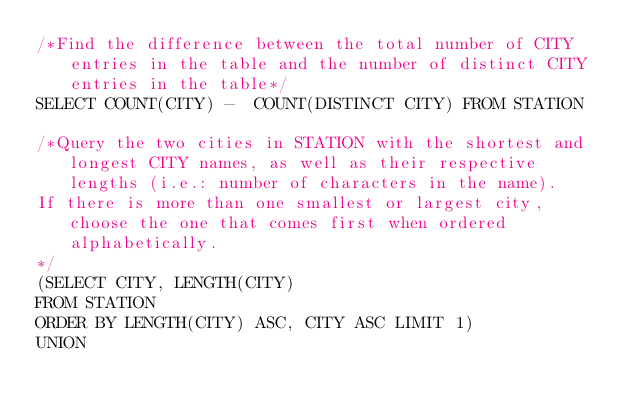<code> <loc_0><loc_0><loc_500><loc_500><_SQL_>/*Find the difference between the total number of CITY entries in the table and the number of distinct CITY entries in the table*/
SELECT COUNT(CITY) -  COUNT(DISTINCT CITY) FROM STATION

/*Query the two cities in STATION with the shortest and longest CITY names, as well as their respective lengths (i.e.: number of characters in the name). 
If there is more than one smallest or largest city, choose the one that comes first when ordered alphabetically.
*/
(SELECT CITY, LENGTH(CITY)
FROM STATION
ORDER BY LENGTH(CITY) ASC, CITY ASC LIMIT 1)
UNION</code> 